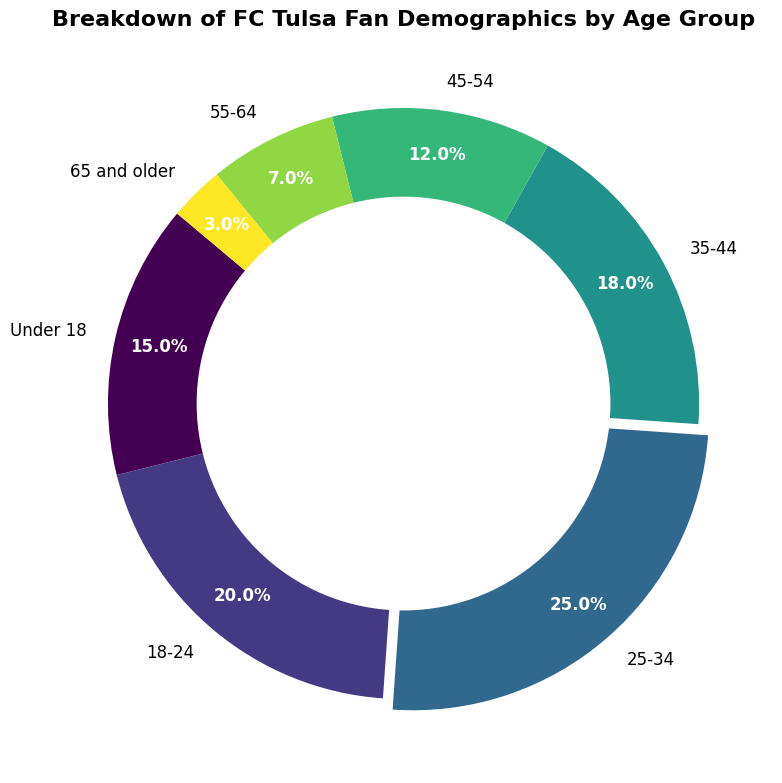What's the largest age group among FC Tulsa fans? Identify the slice with the highest percentage. The '25-34' age group has the highest percentage (25%).
Answer: 25-34 What age group comprises 15% of FC Tulsa fans? Look for the slice with "15%" label. It corresponds to 'Under 18' age group.
Answer: Under 18 What is the total percentage of FC Tulsa fans above 45 years old? Add the percentages for the age groups '45-54', '55-64', and '65 and older': 12% + 7% + 3% = 22%.
Answer: 22% Which is larger, the '35-44' or '45-54' age group? Compare their percentages: '35-44' has 18%, while '45-54' has 12%. '35-44' is larger.
Answer: 35-44 What's the sum of the percentage of fans in the 'Under 18' and '18-24' age groups? Add the percentages for 'Under 18' (15%) and '18-24' (20%): 15% + 20% = 35%.
Answer: 35% Which age group has the smallest representation among FC Tulsa fans? Identify the age group with the smallest percentage. It's '65 and older' with 3%.
Answer: 65 and older Between the '25-34' and '35-44' age groups, which one has a higher percentage? Compare the percentages: '25-34' has 25%, while '35-44' has 18%. '25-34' is higher.
Answer: 25-34 Which age group has a percentage closest to 20%? Look for the age group with a percentage near 20%. The '18-24' age group has exactly 20%.
Answer: 18-24 If you combine the '18-24' and '25-34' age groups, what is the total percentage? Add the percentages for '18-24' (20%) and '25-34' (25%): 20% + 25% = 45%.
Answer: 45% What is the difference in percentage between '35-44' and '55-64' age groups? Subtract the percentage of '55-64' (7%) from '35-44' (18%): 18% - 7% = 11%.
Answer: 11% 